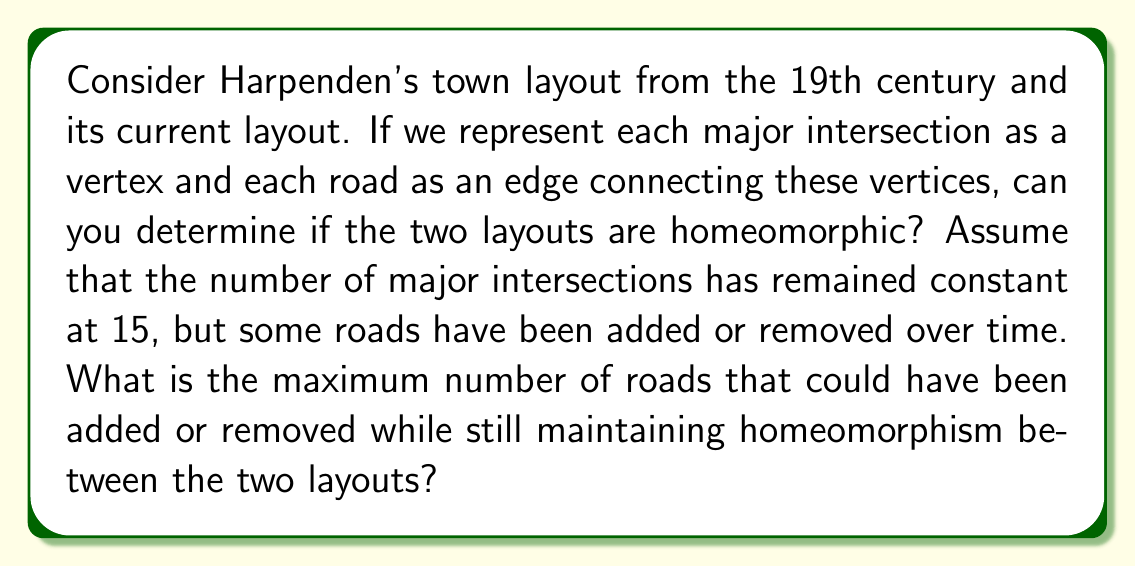Can you solve this math problem? To analyze this problem, we need to consider the concept of homeomorphism in topology and how it applies to graph theory, which we're using to represent the town layouts.

1. Homeomorphism: Two topological spaces are homeomorphic if there exists a continuous bijective function with a continuous inverse between them. In graph theory, this translates to preserving the connectivity of vertices while allowing for the addition or removal of edges.

2. Euler characteristic: For planar graphs (which town layouts typically are), the Euler characteristic remains constant under homeomorphism. The Euler characteristic is given by:

   $$\chi = V - E + F$$

   where $V$ is the number of vertices, $E$ is the number of edges, and $F$ is the number of faces.

3. Given information:
   - The number of vertices (major intersections) remains constant at 15.
   - We need to find the maximum number of roads (edges) that can be added or removed while maintaining homeomorphism.

4. For planar graphs, we can use Euler's formula:

   $$V - E + F = 2$$

5. The maximum number of edges in a planar graph with 15 vertices is given by:

   $$E_{max} = 3V - 6 = 3(15) - 6 = 39$$

6. The minimum number of edges to keep the graph connected is:

   $$E_{min} = V - 1 = 15 - 1 = 14$$

7. Therefore, the range of possible edges while maintaining planarity and connectivity is 14 to 39.

8. The maximum number of edges that can be added or removed while maintaining homeomorphism is the difference between these two values:

   $$39 - 14 = 25$$

This means that up to 25 roads could be added or removed between the 19th-century layout and the current layout while still allowing for a homeomorphic mapping between the two.
Answer: The maximum number of roads that could have been added or removed while still maintaining homeomorphism between the two layouts is 25. 